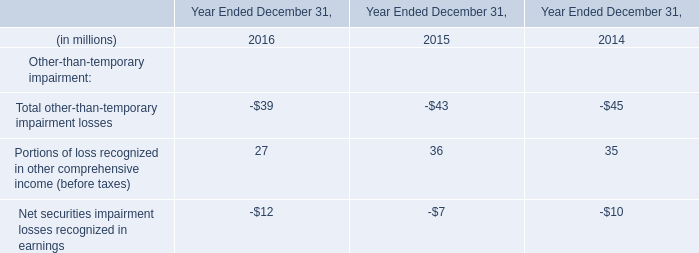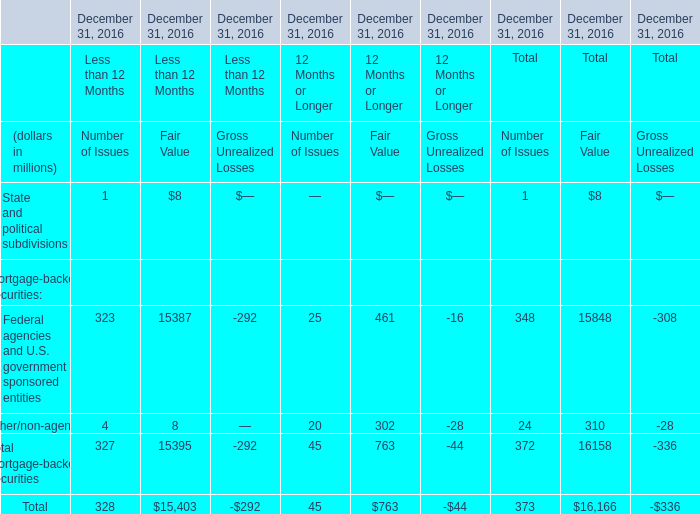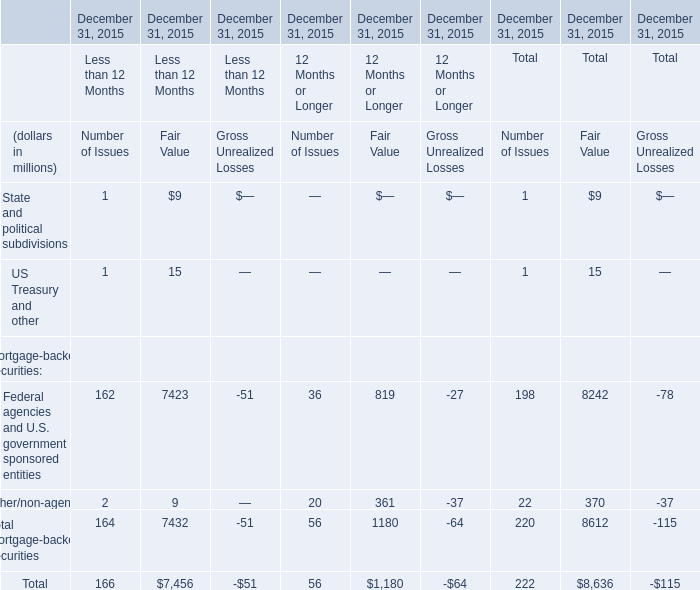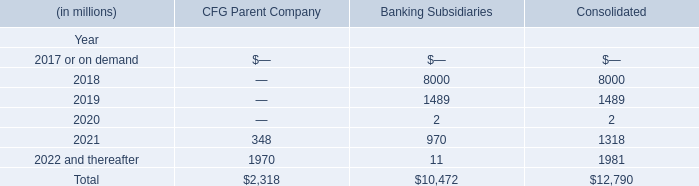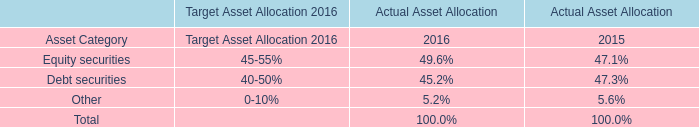Which year is Portions of loss recognized in other comprehensive income (before taxes) the highest? 
Answer: 2015. 